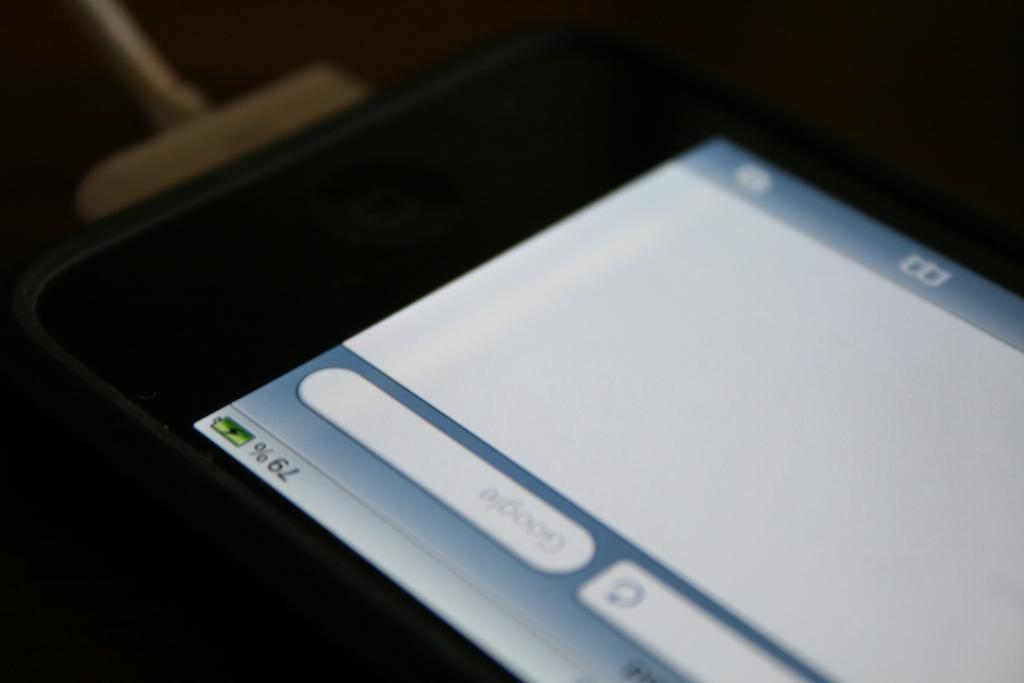<image>
Give a short and clear explanation of the subsequent image. The battery level of this device is at 79 percent. 